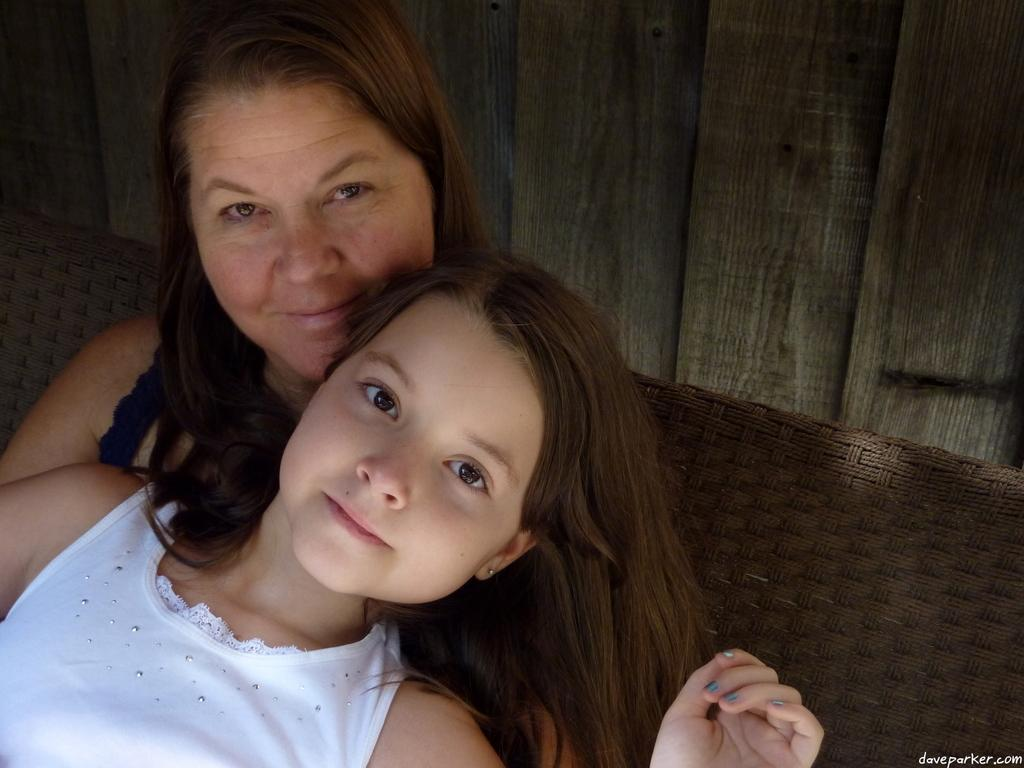How many people are in the image? There are two persons in the image. What is the background of the image? The persons are in front of a wooden wall. Can you describe the object behind the two persons? Unfortunately, the object behind the two persons cannot be clearly identified from the provided facts. What type of pan is hanging on the line in the image? There is no pan or line present in the image. How many thumbs can be seen in the image? The number of thumbs cannot be determined from the provided facts, as the appearance of the persons' hands is not mentioned. 